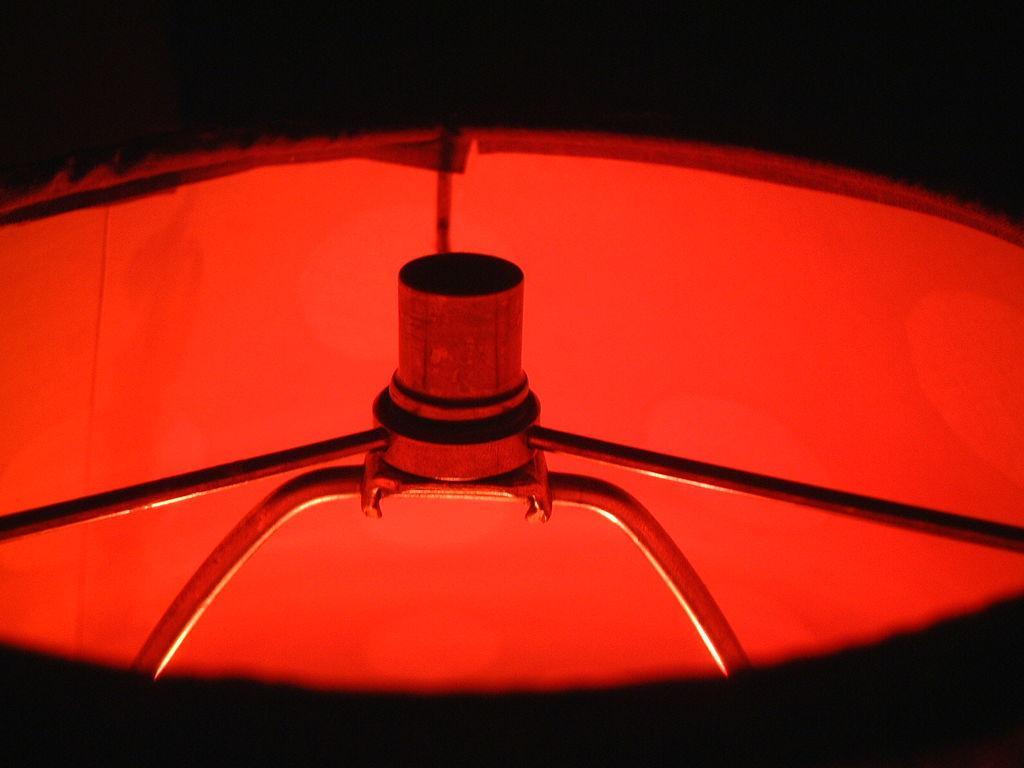Can you describe this image briefly? In the middle of this image there is a metal object. Around this there is a red color object which seems to be a cloth. The background is in black color. 